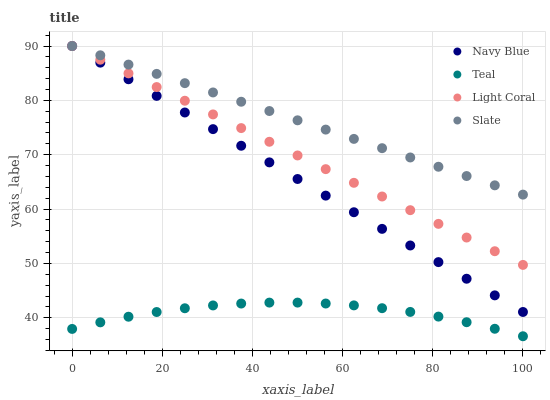Does Teal have the minimum area under the curve?
Answer yes or no. Yes. Does Slate have the maximum area under the curve?
Answer yes or no. Yes. Does Navy Blue have the minimum area under the curve?
Answer yes or no. No. Does Navy Blue have the maximum area under the curve?
Answer yes or no. No. Is Navy Blue the smoothest?
Answer yes or no. Yes. Is Teal the roughest?
Answer yes or no. Yes. Is Slate the smoothest?
Answer yes or no. No. Is Slate the roughest?
Answer yes or no. No. Does Teal have the lowest value?
Answer yes or no. Yes. Does Navy Blue have the lowest value?
Answer yes or no. No. Does Slate have the highest value?
Answer yes or no. Yes. Does Teal have the highest value?
Answer yes or no. No. Is Teal less than Navy Blue?
Answer yes or no. Yes. Is Navy Blue greater than Teal?
Answer yes or no. Yes. Does Light Coral intersect Slate?
Answer yes or no. Yes. Is Light Coral less than Slate?
Answer yes or no. No. Is Light Coral greater than Slate?
Answer yes or no. No. Does Teal intersect Navy Blue?
Answer yes or no. No. 